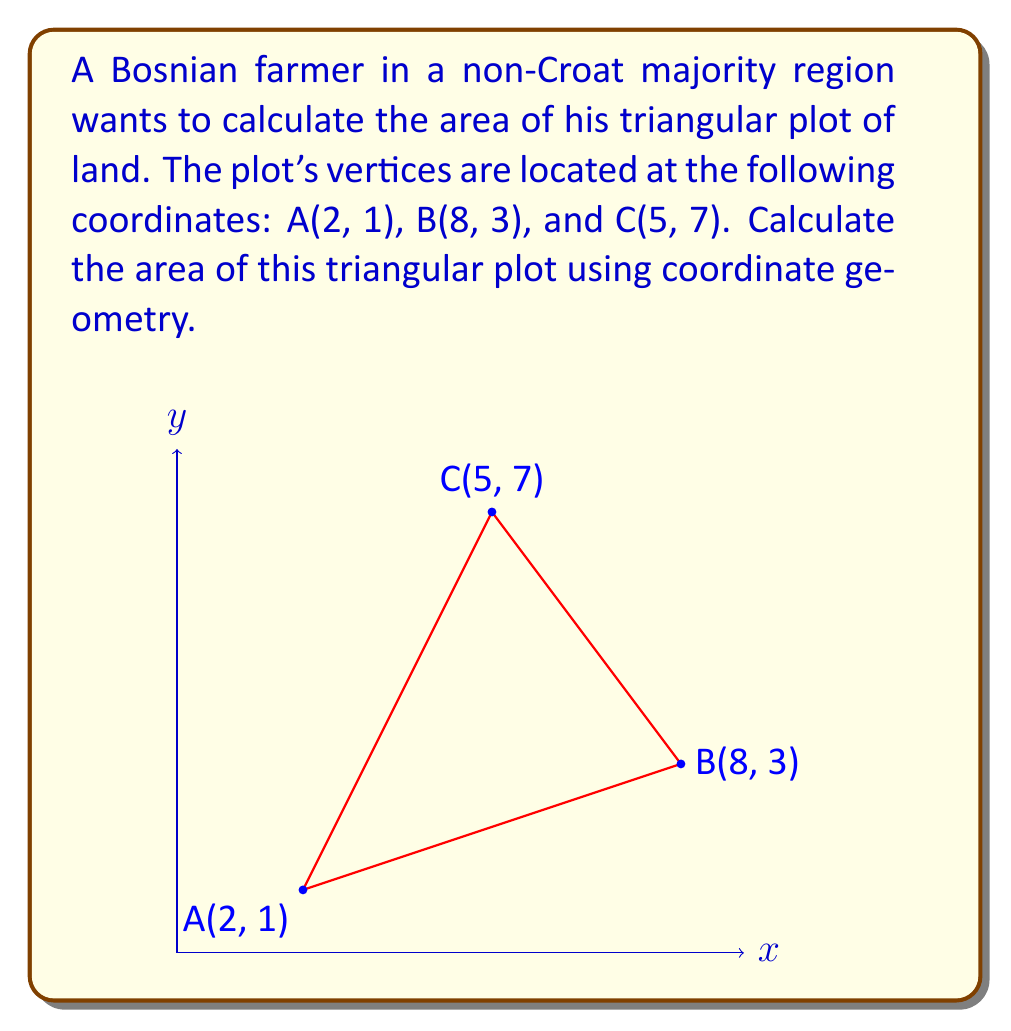Could you help me with this problem? To calculate the area of a triangle using coordinate geometry, we can use the formula:

$$ \text{Area} = \frac{1}{2}|\det(\mathbf{v_1}, \mathbf{v_2})|$$

where $\mathbf{v_1}$ and $\mathbf{v_2}$ are vectors representing two sides of the triangle.

Step 1: Choose two vectors.
Let's choose $\overrightarrow{AB}$ and $\overrightarrow{AC}$ as our vectors.

$\overrightarrow{AB} = (8-2, 3-1) = (6, 2)$
$\overrightarrow{AC} = (5-2, 7-1) = (3, 6)$

Step 2: Set up the determinant.
$$\det(\mathbf{v_1}, \mathbf{v_2}) = \begin{vmatrix} 
6 & 3 \\
2 & 6
\end{vmatrix}$$

Step 3: Calculate the determinant.
$$\det(\mathbf{v_1}, \mathbf{v_2}) = (6 \times 6) - (3 \times 2) = 36 - 6 = 30$$

Step 4: Apply the area formula.
$$ \text{Area} = \frac{1}{2}|30| = 15 $$

Therefore, the area of the triangular plot is 15 square units.
Answer: The area of the triangular plot is 15 square units. 